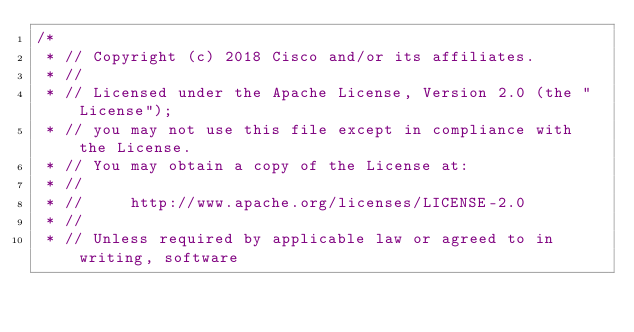Convert code to text. <code><loc_0><loc_0><loc_500><loc_500><_Go_>/*
 * // Copyright (c) 2018 Cisco and/or its affiliates.
 * //
 * // Licensed under the Apache License, Version 2.0 (the "License");
 * // you may not use this file except in compliance with the License.
 * // You may obtain a copy of the License at:
 * //
 * //     http://www.apache.org/licenses/LICENSE-2.0
 * //
 * // Unless required by applicable law or agreed to in writing, software</code> 